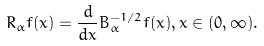<formula> <loc_0><loc_0><loc_500><loc_500>R _ { \alpha } f ( x ) = \frac { d } { d x } B _ { \alpha } ^ { - 1 / 2 } f ( x ) , x \in ( 0 , \infty ) .</formula> 